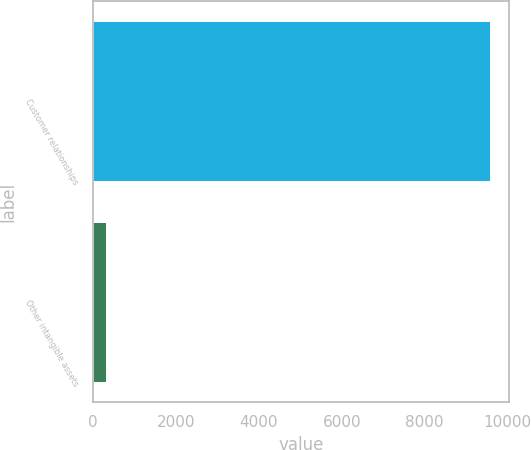Convert chart. <chart><loc_0><loc_0><loc_500><loc_500><bar_chart><fcel>Customer relationships<fcel>Other intangible assets<nl><fcel>9565<fcel>317<nl></chart> 